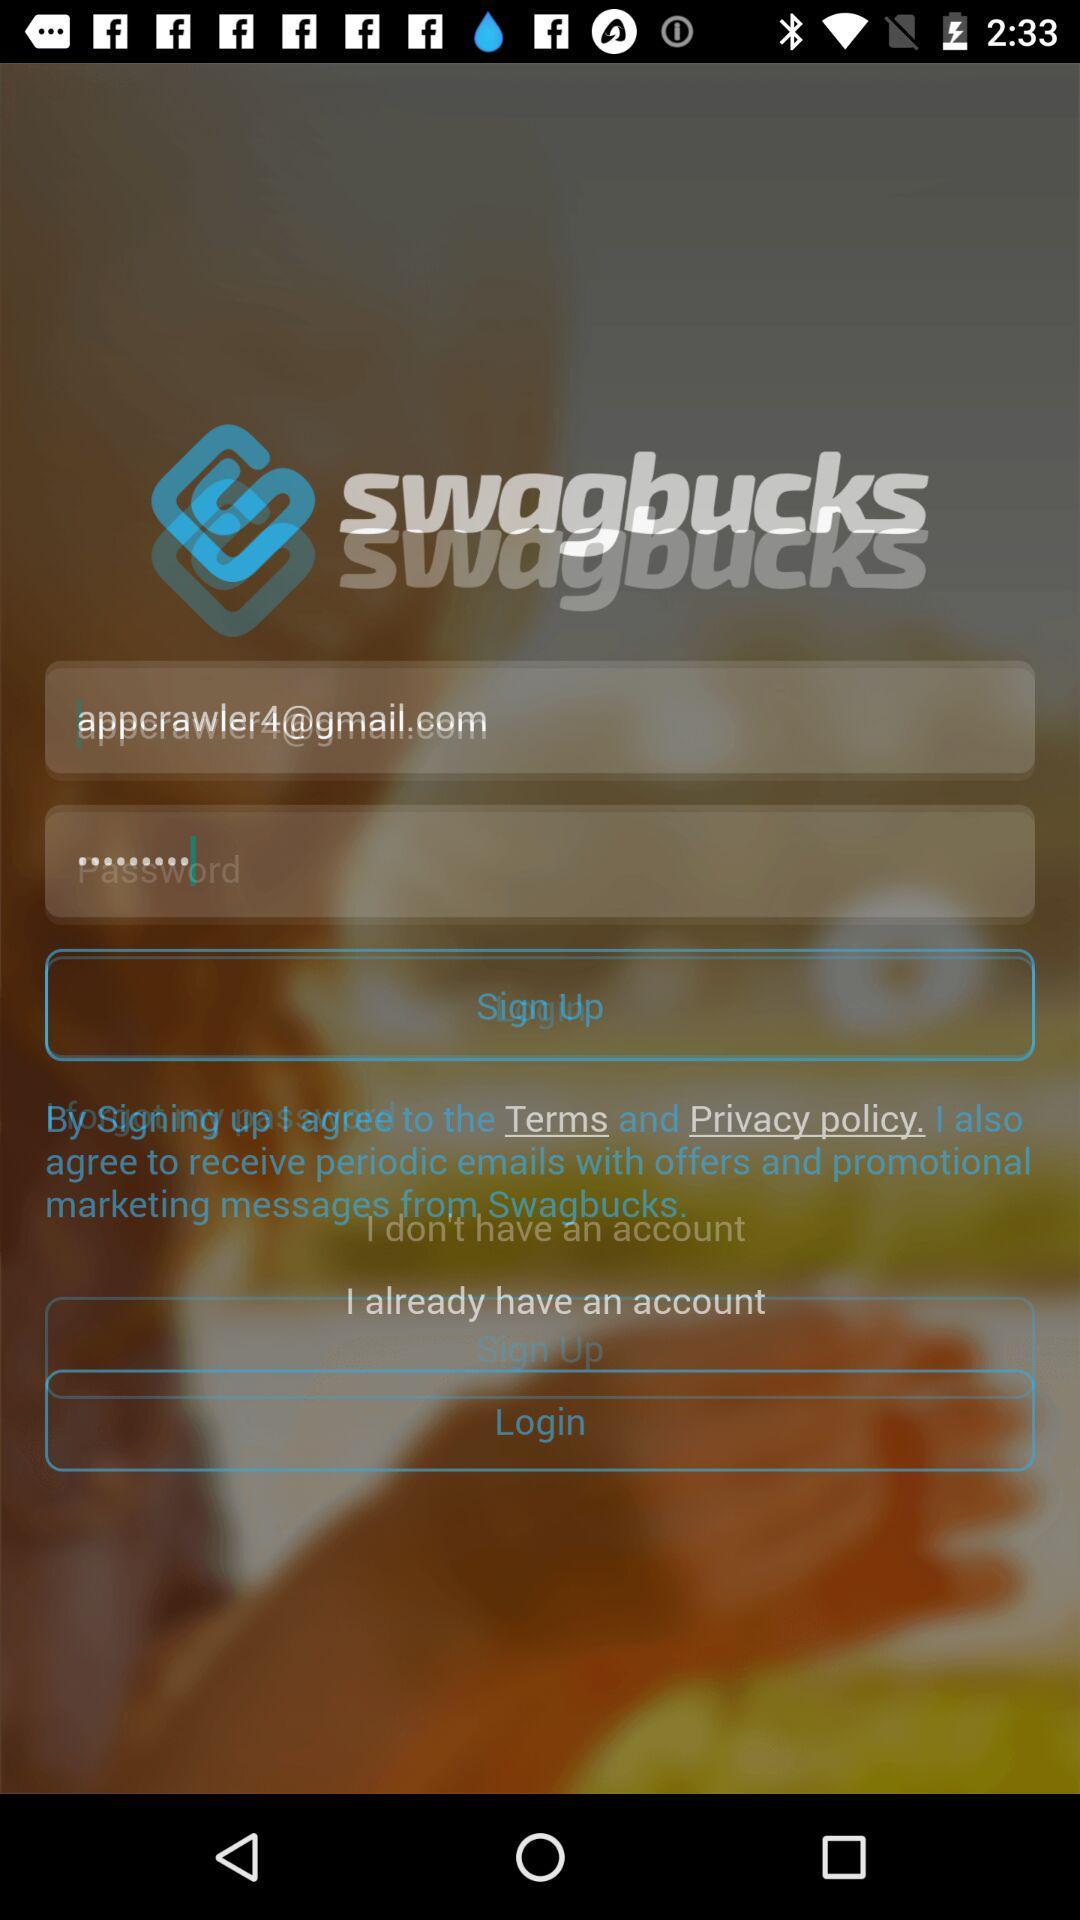What is the email address? The email address is appcrawler4@gmail.com. 